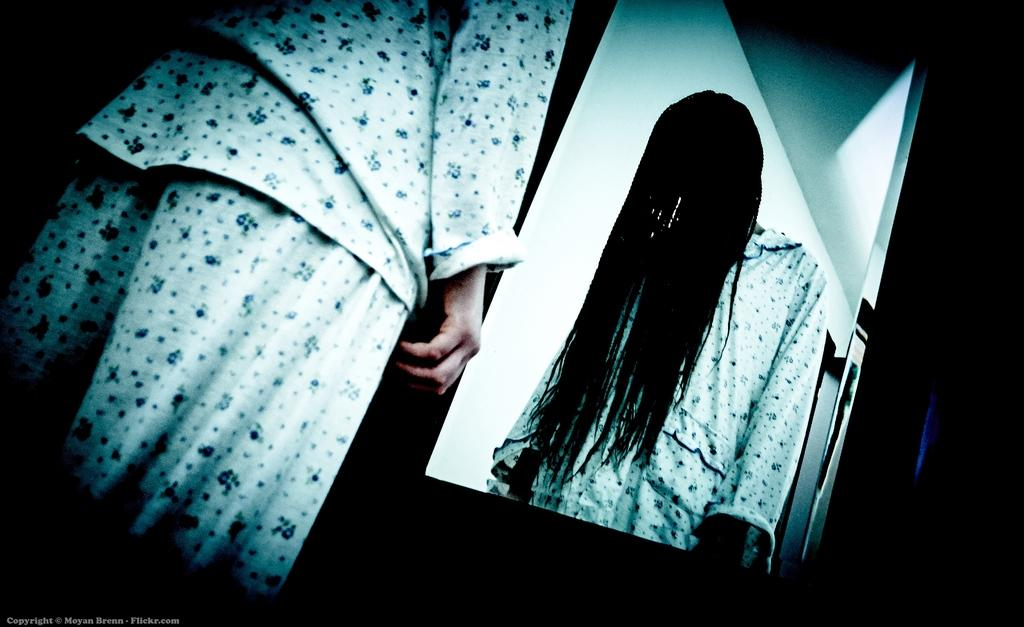Who is present in the image? There is a woman in the image. What is the woman doing in the image? The woman is standing in the image. What object is visible in front of the woman? There is a mirror in front of the woman. What type of fact can be seen in the image? There is no fact present in the image; it features a woman standing in front of a mirror. What reward is the woman holding in the image? There is no reward visible in the image; the woman is simply standing in front of a mirror. 